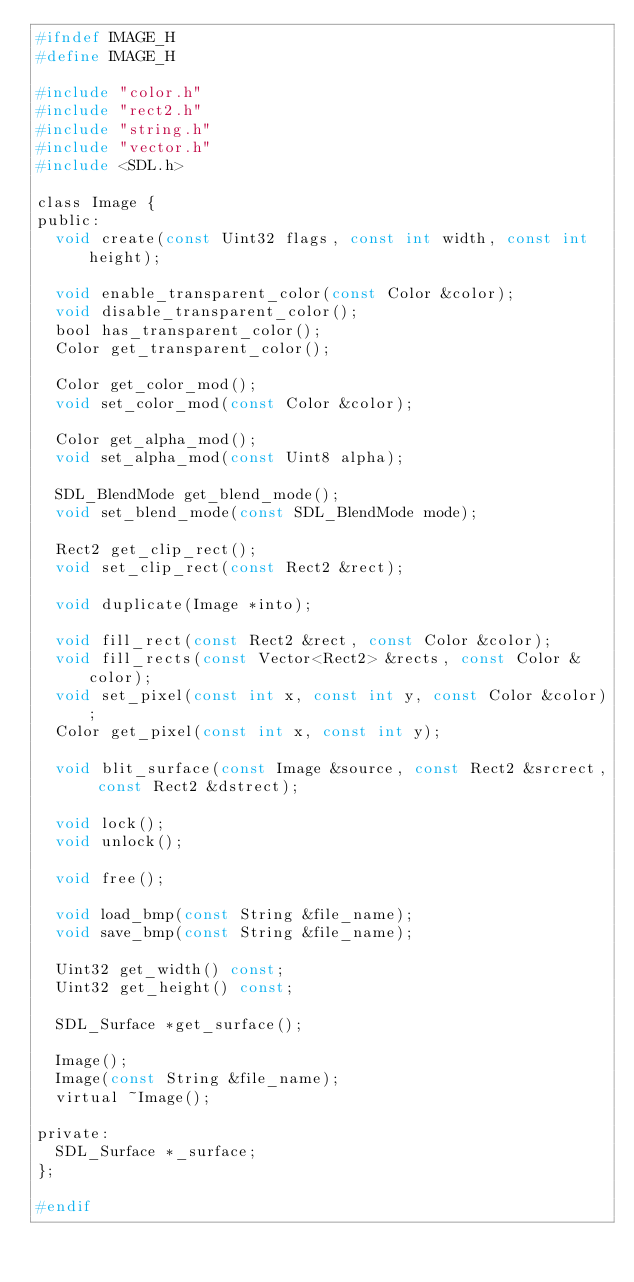Convert code to text. <code><loc_0><loc_0><loc_500><loc_500><_C_>#ifndef IMAGE_H
#define IMAGE_H

#include "color.h"
#include "rect2.h"
#include "string.h"
#include "vector.h"
#include <SDL.h>

class Image {
public:
	void create(const Uint32 flags, const int width, const int height);

	void enable_transparent_color(const Color &color);
	void disable_transparent_color();
	bool has_transparent_color();
	Color get_transparent_color();

	Color get_color_mod();
	void set_color_mod(const Color &color);

	Color get_alpha_mod();
	void set_alpha_mod(const Uint8 alpha);

	SDL_BlendMode get_blend_mode();
	void set_blend_mode(const SDL_BlendMode mode);

	Rect2 get_clip_rect();
	void set_clip_rect(const Rect2 &rect);

	void duplicate(Image *into);

	void fill_rect(const Rect2 &rect, const Color &color);
	void fill_rects(const Vector<Rect2> &rects, const Color &color);
	void set_pixel(const int x, const int y, const Color &color);
	Color get_pixel(const int x, const int y);

	void blit_surface(const Image &source, const Rect2 &srcrect, const Rect2 &dstrect);

	void lock();
	void unlock();

	void free();

	void load_bmp(const String &file_name);
	void save_bmp(const String &file_name);

	Uint32 get_width() const;
	Uint32 get_height() const;

	SDL_Surface *get_surface();

	Image();
	Image(const String &file_name);
	virtual ~Image();

private:
	SDL_Surface *_surface;
};

#endif</code> 